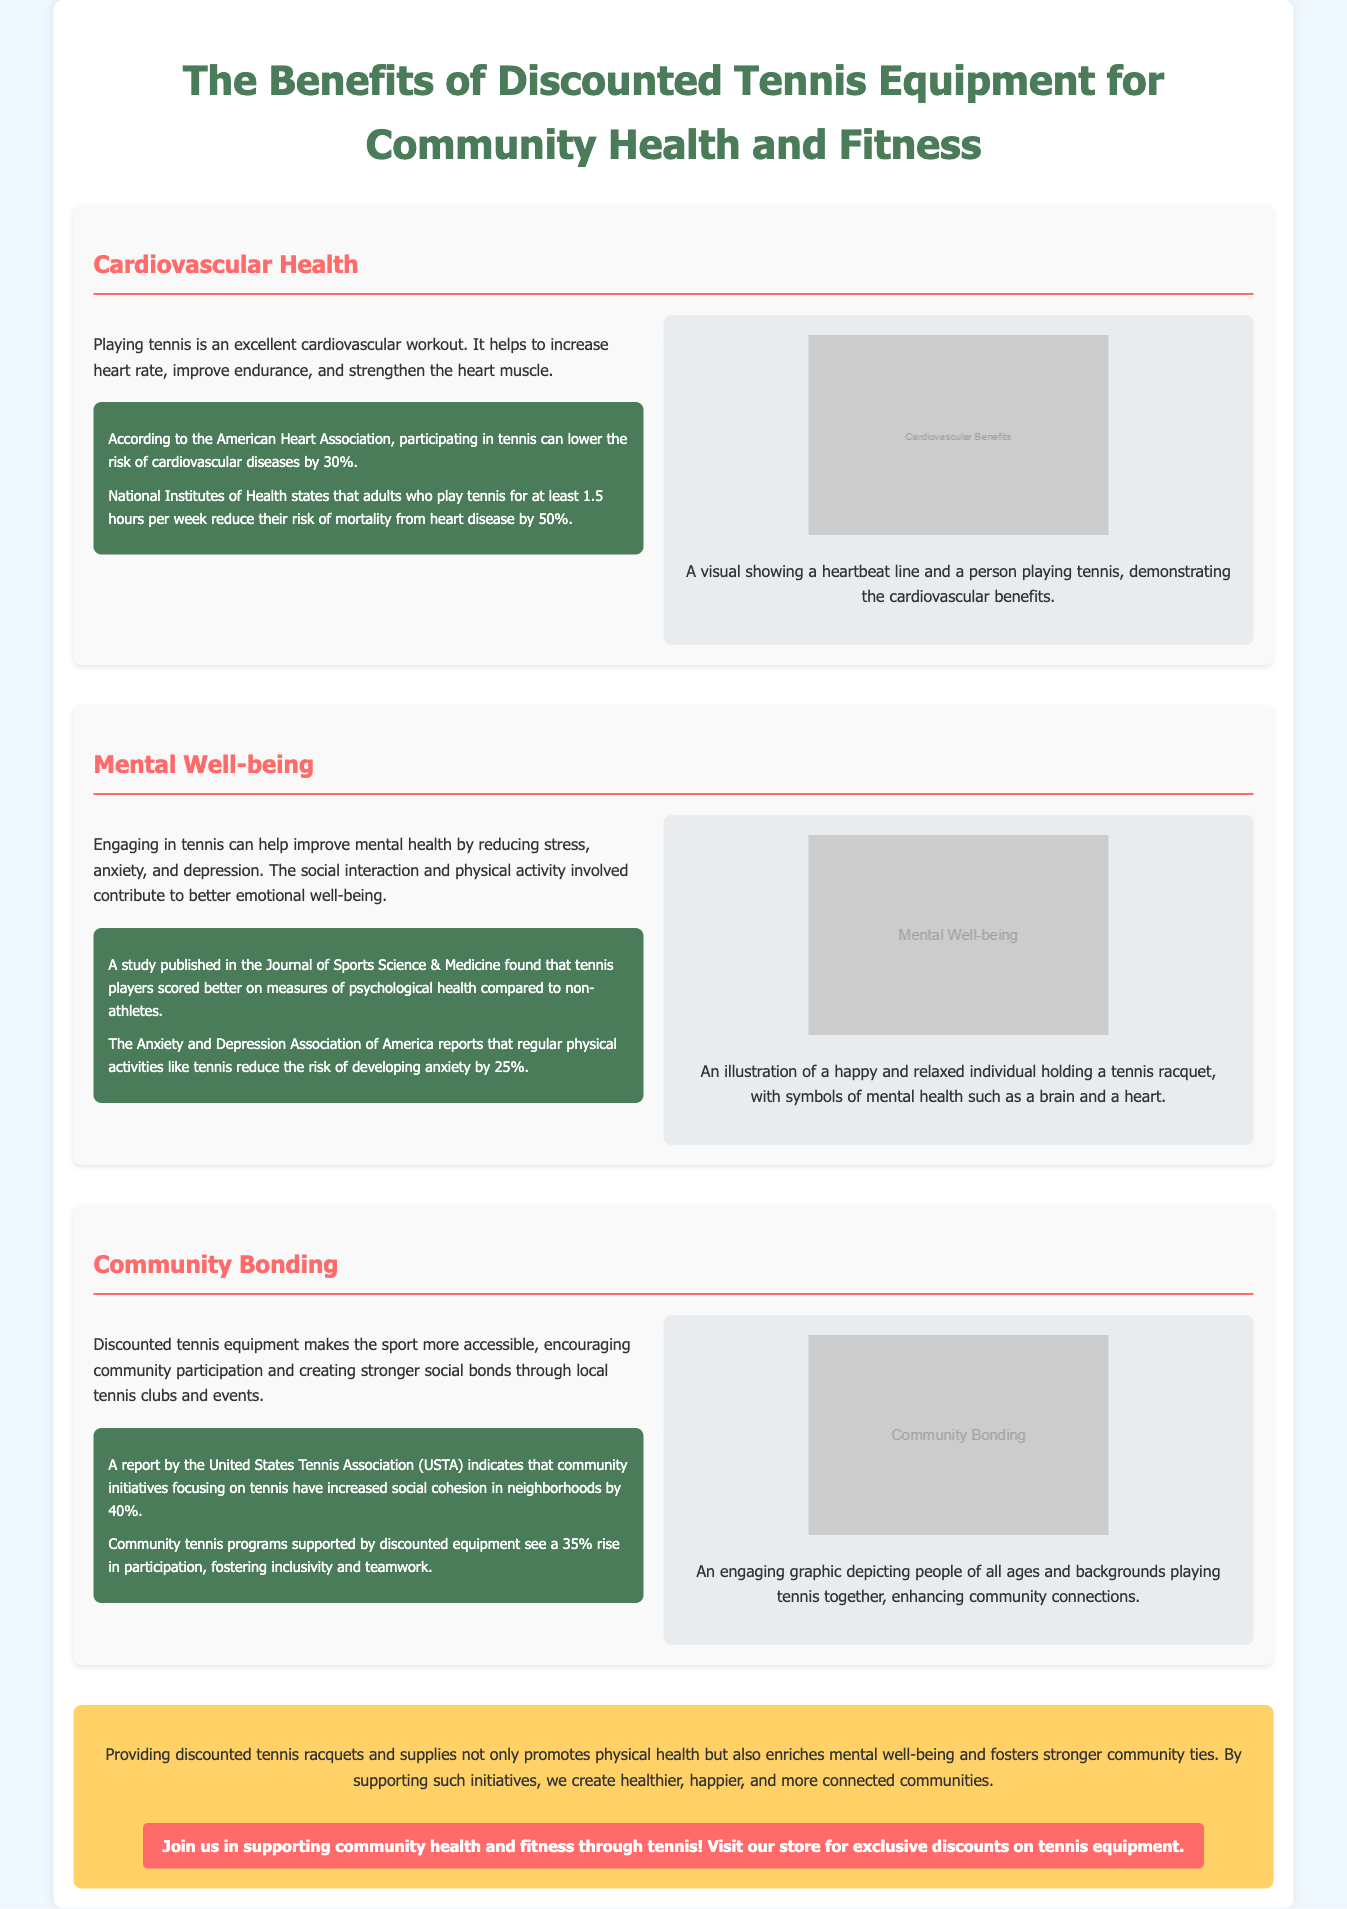What percentage can participating in tennis lower the risk of cardiovascular diseases? According to the American Heart Association, participating in tennis can lower the risk of cardiovascular diseases by 30%.
Answer: 30% What do tennis players score better in compared to non-athletes? A study published in the Journal of Sports Science & Medicine found that tennis players scored better on measures of psychological health.
Answer: Psychological health What is the increase in social cohesion reported by the United States Tennis Association? A report by the United States Tennis Association (USTA) indicates that community initiatives focusing on tennis have increased social cohesion in neighborhoods by 40%.
Answer: 40% How much can discounted equipment increase participation in community tennis programs? Community tennis programs supported by discounted equipment see a 35% rise in participation.
Answer: 35% What is one mental health benefit of engaging in tennis? Engaging in tennis can help improve mental health by reducing stress, anxiety, and depression.
Answer: Reducing stress What visual representation is included for cardiovascular health? A visual showing a heartbeat line and a person playing tennis, demonstrating the cardiovascular benefits.
Answer: Heartbeat line and person playing tennis What color is used for the background of the conclusion section? The conclusion section has a background color of #ffd166.
Answer: #ffd166 What does the graphic depicting community bonding show? An engaging graphic depicting people of all ages and backgrounds playing tennis together.
Answer: People playing tennis together 